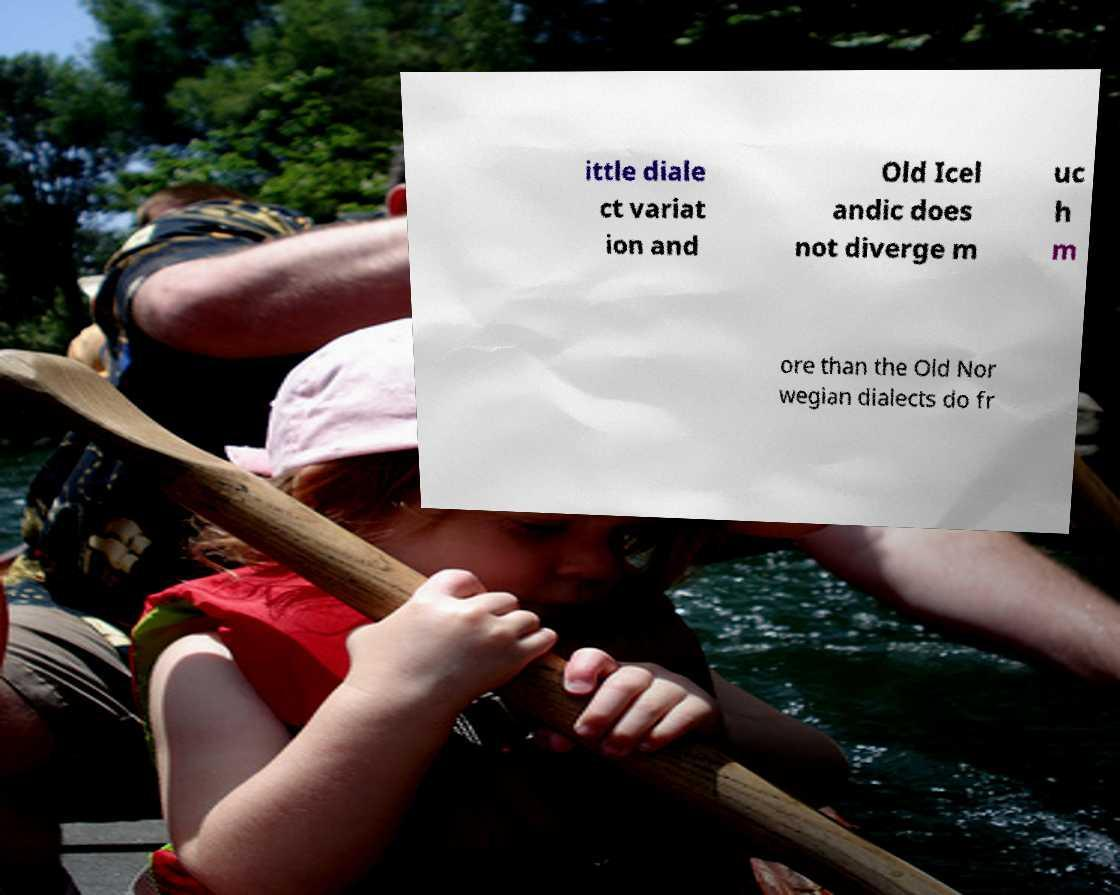Could you assist in decoding the text presented in this image and type it out clearly? ittle diale ct variat ion and Old Icel andic does not diverge m uc h m ore than the Old Nor wegian dialects do fr 